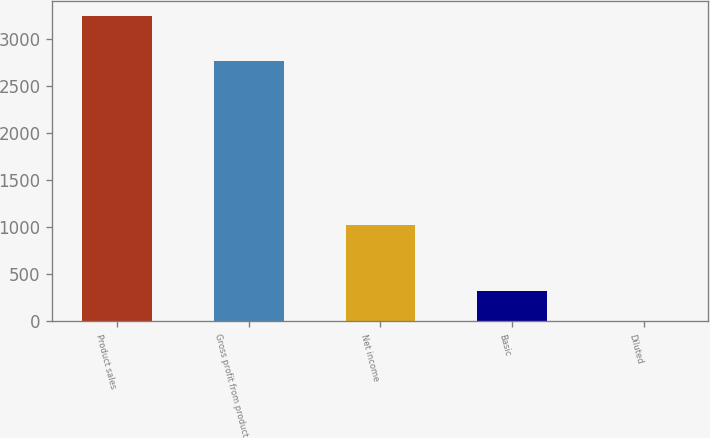Convert chart to OTSL. <chart><loc_0><loc_0><loc_500><loc_500><bar_chart><fcel>Product sales<fcel>Gross profit from product<fcel>Net income<fcel>Basic<fcel>Diluted<nl><fcel>3238<fcel>2761<fcel>1019<fcel>324.68<fcel>0.98<nl></chart> 